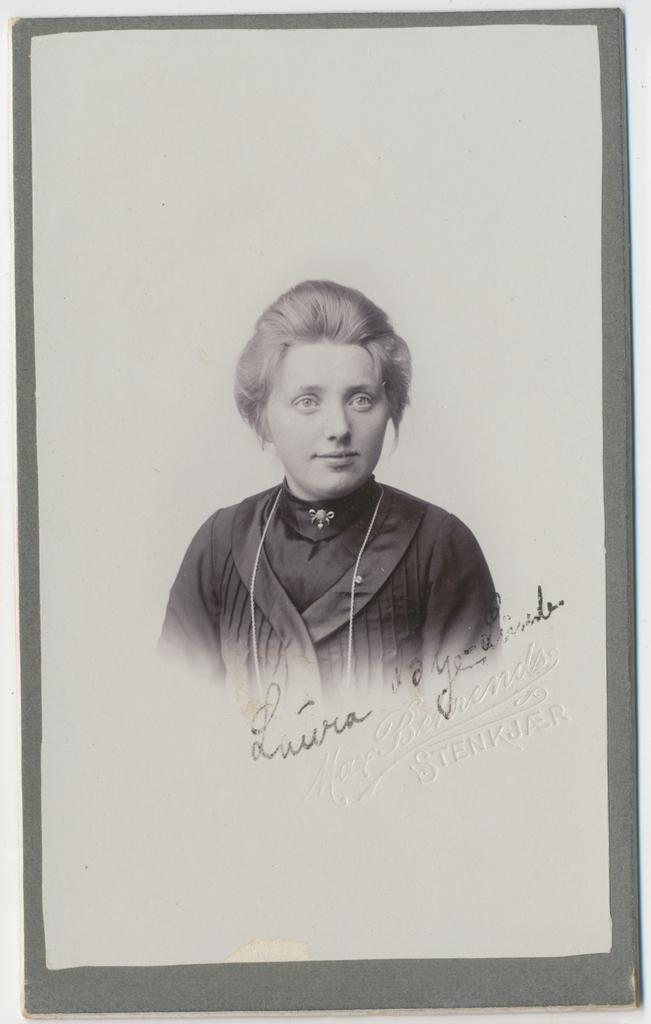What is depicted in the image? There is a sketch of a woman in the image. Can you describe any additional details about the sketch? There is writing on the sketch. Is there a water source visible in the image? No, there is no water source visible in the image. Is there a turkey or any indication of a turkey in the image? No, there is no turkey or any indication of a turkey in the image. 